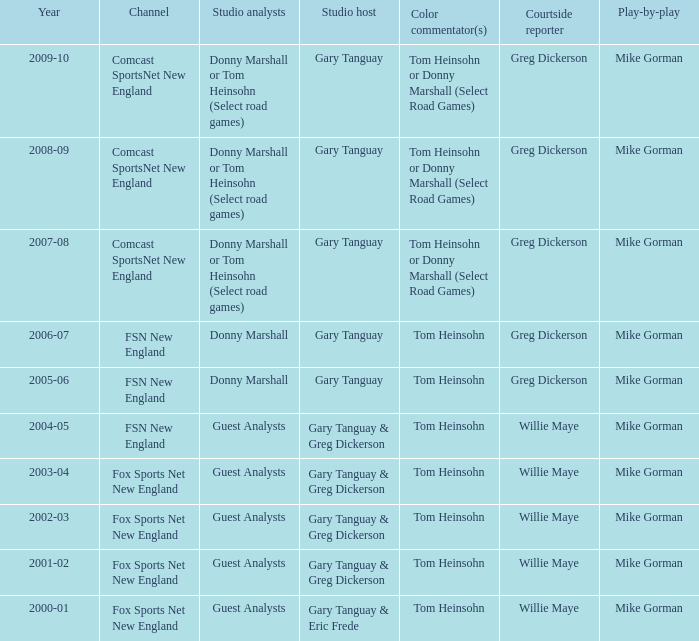Which Color commentator has a Channel of fsn new england, and a Year of 2004-05? Tom Heinsohn. 